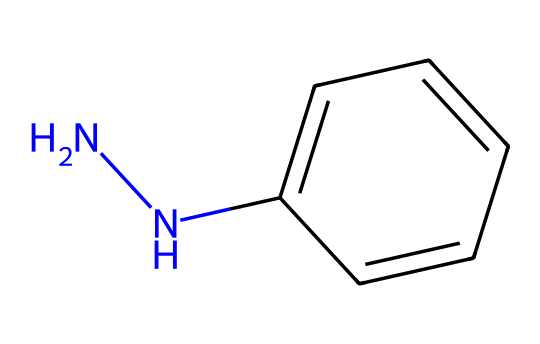What is the molecular formula of phenylhydrazine? To determine the molecular formula, count the atoms for each element present in the SMILES representation. There are 6 carbon atoms (c1ccccc1), 8 hydrogen atoms, and 2 nitrogen atoms (NN), leading to the molecular formula C6H8N2.
Answer: C6H8N2 How many nitrogen atoms are in phenylhydrazine? By observing the SMILES notation, we see "NN," which indicates the presence of 2 nitrogen atoms connected by a single bond.
Answer: 2 What type of functional group is present in phenylhydrazine? The presence of the hydrazine part (NN) signifies that it contains a hydrazine functional group. This is specifically a diamine functional group due to the two nitrogen atoms.
Answer: hydrazine How many rings are present in phenylhydrazine? The molecular structure provided does not depict any cyclic arrangements; thus, there are no rings present in phenylhydrazine.
Answer: 0 What is the hybridization of the nitrogen in phenylhydrazine? In this structure, the nitrogen atoms are each bonded to two other atoms (one nitrogen and one carbon), leading to sp2 hybridization due to the trigonal planar arrangement around each nitrogen atom.
Answer: sp2 Which part of the structure contributes to its aromatic character? The phenyl (c1ccccc1) portion of the structure consists of a benzene ring, which is essential for aromaticity due to its conjugated pi electron system.
Answer: phenyl What is the primary use of phenylhydrazine in pharmaceuticals? Phenylhydrazine is commonly utilized as a reagent for the synthesis of various pharmaceutical compounds, particularly for the formation of hydrazones and for detecting carbonyl groups.
Answer: synthesis 